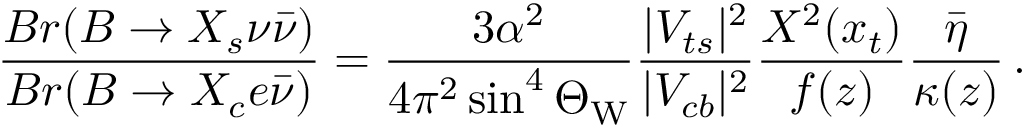<formula> <loc_0><loc_0><loc_500><loc_500>\frac { B r ( B \to X _ { s } \nu \bar { \nu } ) } { B r ( B \to X _ { c } e \bar { \nu } ) } = \frac { 3 \alpha ^ { 2 } } { 4 \pi ^ { 2 } \sin ^ { 4 } \Theta _ { W } } \frac { | V _ { t s } | ^ { 2 } } { | V _ { c b } | ^ { 2 } } \frac { X ^ { 2 } ( x _ { t } ) } { f ( z ) } \frac { \bar { \eta } } { \kappa ( z ) } \, .</formula> 